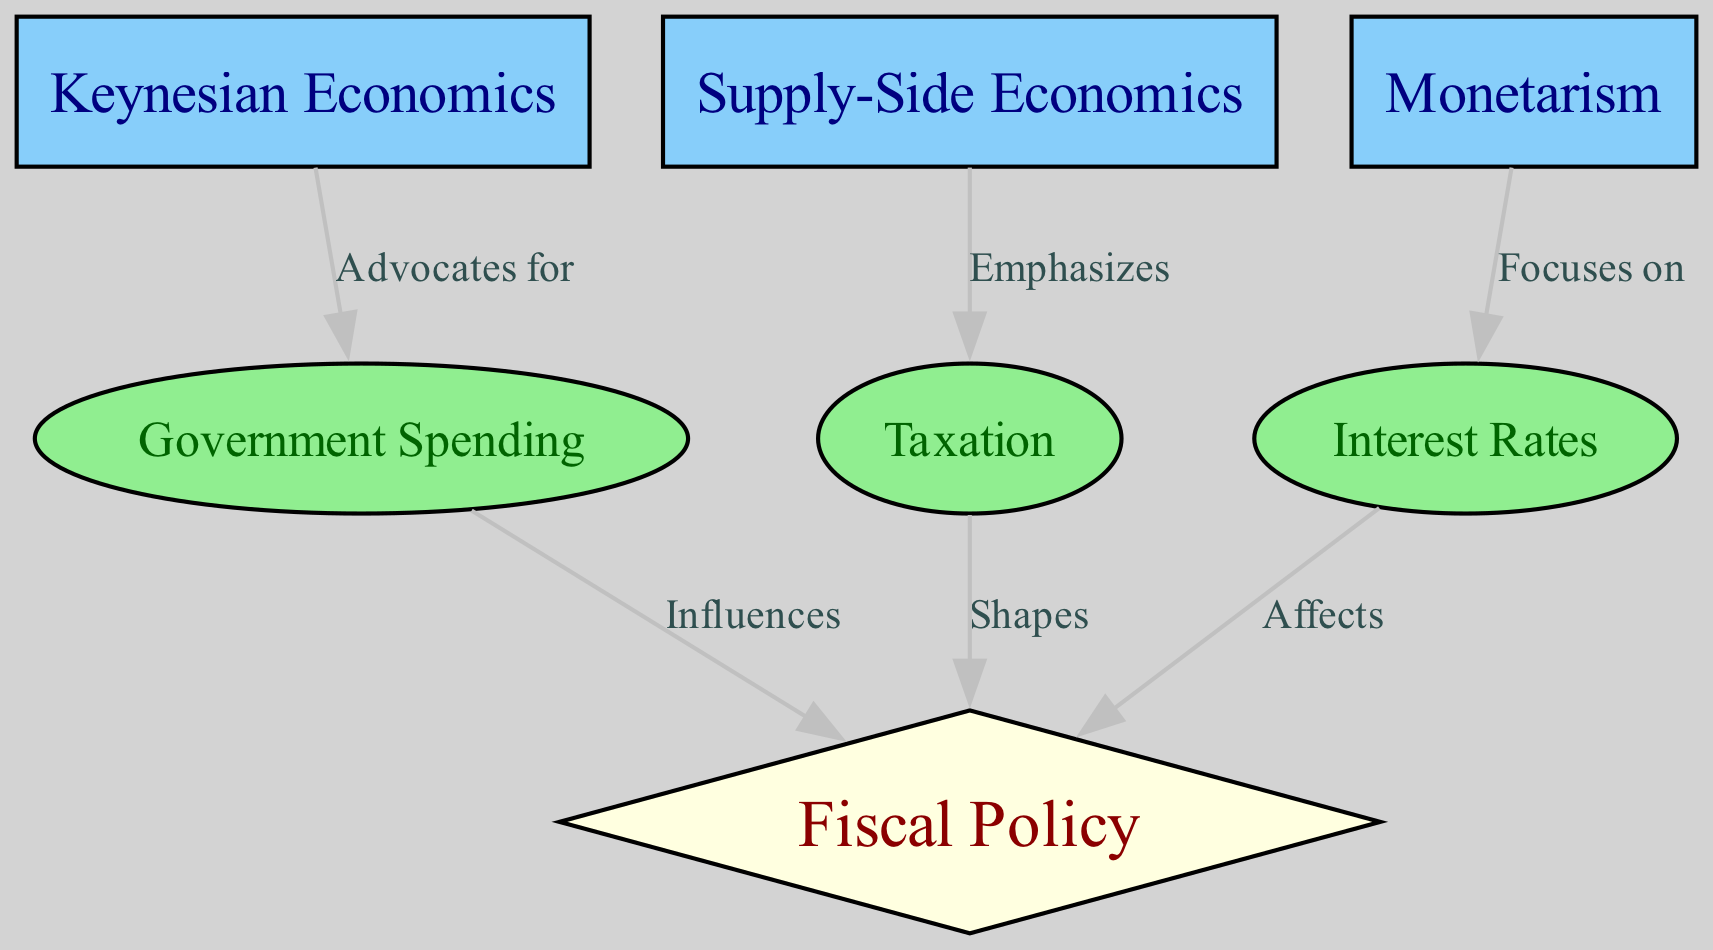What is the total number of nodes in the diagram? The diagram has seven nodes listed in the provided data under the "nodes" key. These include three economic theories, three economic factors, and one fiscal policy node.
Answer: 7 Which economic theory advocates for government spending? According to the edges in the diagram, "Keynesian Economics" is linked to "Government Spending" with the label "Advocates for." This establishes a clear relationship indicating that Keynesian Economics promotes this economic action.
Answer: Keynesian Economics What type of shape represents fiscal policy in the diagram? The diagram categorizes fiscal policy as a diamond shape, as observed in the characteristics assigned to the node labeled "Fiscal Policy." This design choice visually distinguishes it from other types of nodes.
Answer: Diamond What influences fiscal policy according to the diagram? The diagram indicates that "Government Spending" influences "Fiscal Policy," as illustrated by the edge connecting these nodes with the label "Influences." This implies a direct relationship where changes in government spending can affect fiscal policy decisions.
Answer: Government Spending Which economic theory is associated with taxation? The edge labeled "Emphasizes" connects "Supply-Side Economics" to "Taxation," suggesting a focus on tax policies as part of supply-side economic theory. Therefore, this theory is most directly associated with taxation in the diagram.
Answer: Supply-Side Economics What is the effect of interest rates on fiscal policy? According to the diagram, the edge between "Interest Rates" and "Fiscal Policy" is labeled "Affects," implying that changes in interest rates have a direct effect on fiscal policy. This relationship emphasizes how monetary aspects can influence government financial strategies.
Answer: Affects Which node emphasizes taxation? In the diagram, the edge labeled "Emphasizes" connects "Supply-Side Economics" and "Taxation," indicating that taxation is a central theme within supply-side economic theory, thus clearly defining its emphasis on tax-related policies.
Answer: Taxation What economic concept focuses primarily on interest rates? The reference to monetarism in the diagram along with the edge labeled "Focuses on" demonstrates that this economic theory centers its attention on interest rates as a critical component of economic policy and monetary control.
Answer: Monetarism 